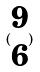Convert formula to latex. <formula><loc_0><loc_0><loc_500><loc_500>( \begin{matrix} 9 \\ 6 \end{matrix} )</formula> 